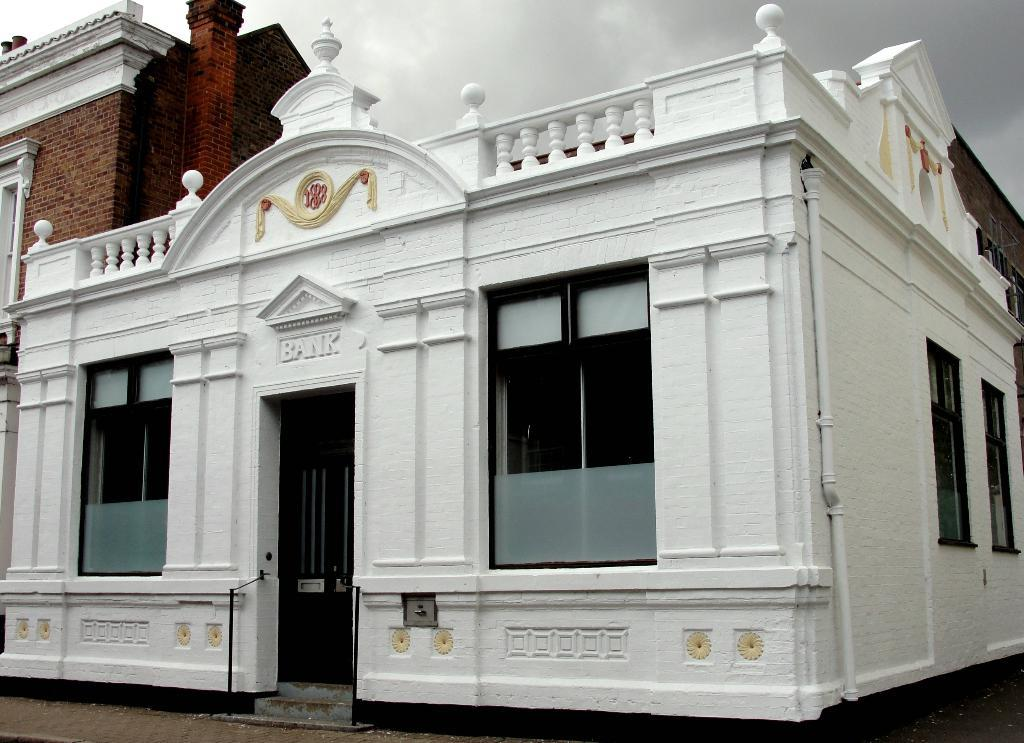What type of structures can be seen in the image? There are buildings in the image. What architectural features are visible on the buildings? There are windows and at least one door visible on the buildings. What else can be seen in the image besides the buildings? There are pipelines and a floor visible in the image. What is visible in the background of the image? The sky is visible in the image, and there are clouds in the sky. Where is the honey stored in the image? There is no honey present in the image. What type of stove can be seen in the image? There is no stove present in the image. 